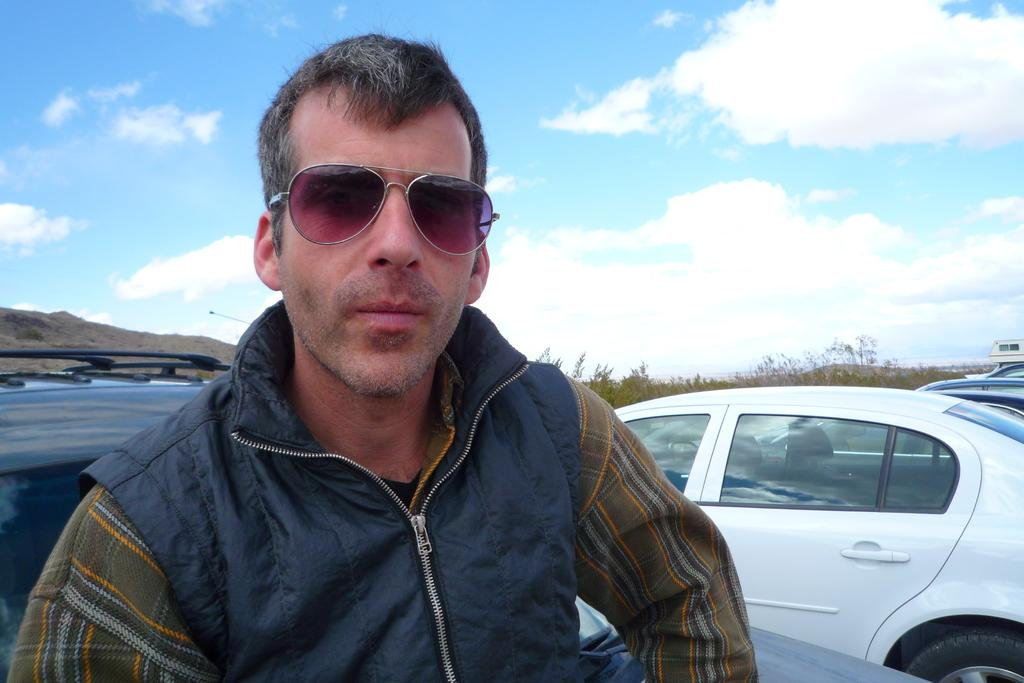Who is present in the image? There is a man in the image. What is the man wearing on his face? The man is wearing goggles. What can be seen in the background of the image? There are vehicles on a path, trees, hills, and the sky visible in the background of the image. How many dogs are present in the image? There are no dogs present in the image. What type of camp can be seen in the image? There is no camp present in the image. 